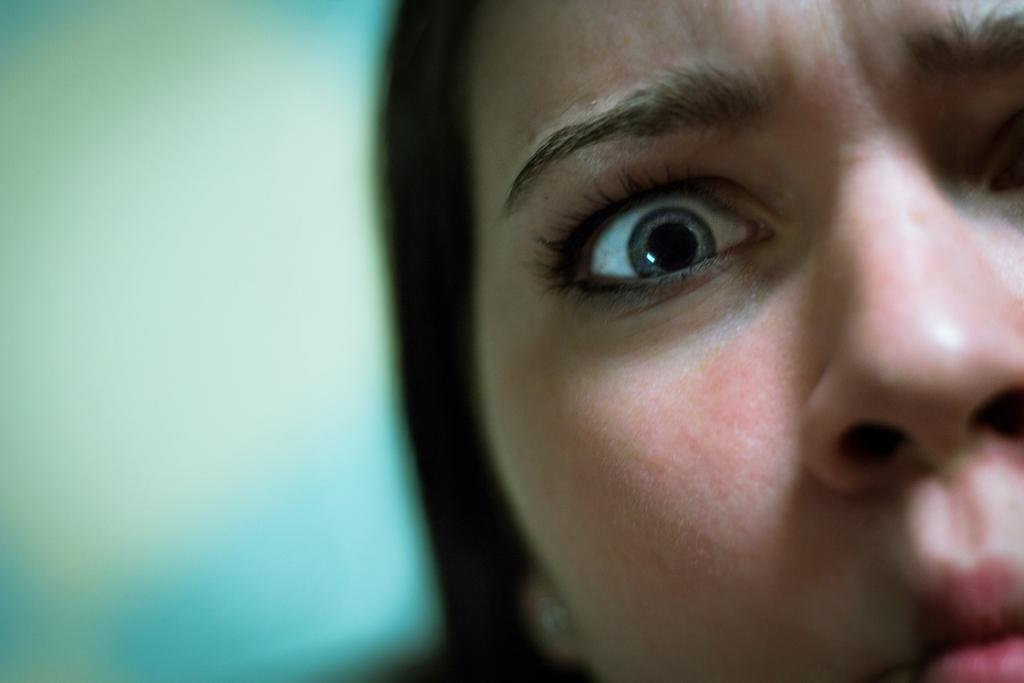Who is the main subject in the image? There is a woman in the image. How much of the woman's face can be seen? Only half of the woman's face is visible in the image. What emotion is the woman expressing? The woman's expression is furious. Can you describe the background of the image? The background of the image is blurry. What type of pipe can be seen in the woman's hand in the image? There is no pipe present in the image; the woman's hands are not visible. Can you tell me how many brothers the woman has in the image? There is no information about the woman's family in the image, so it is impossible to determine the number of brothers she has. 